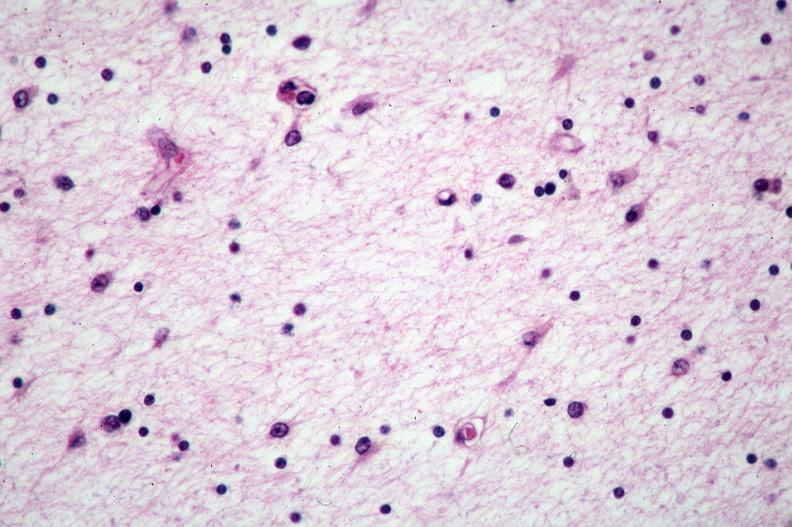s nervous present?
Answer the question using a single word or phrase. Yes 